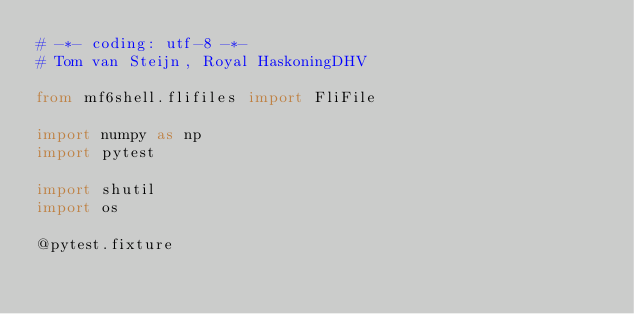Convert code to text. <code><loc_0><loc_0><loc_500><loc_500><_Python_># -*- coding: utf-8 -*-
# Tom van Steijn, Royal HaskoningDHV

from mf6shell.flifiles import FliFile

import numpy as np
import pytest

import shutil
import os

@pytest.fixture</code> 